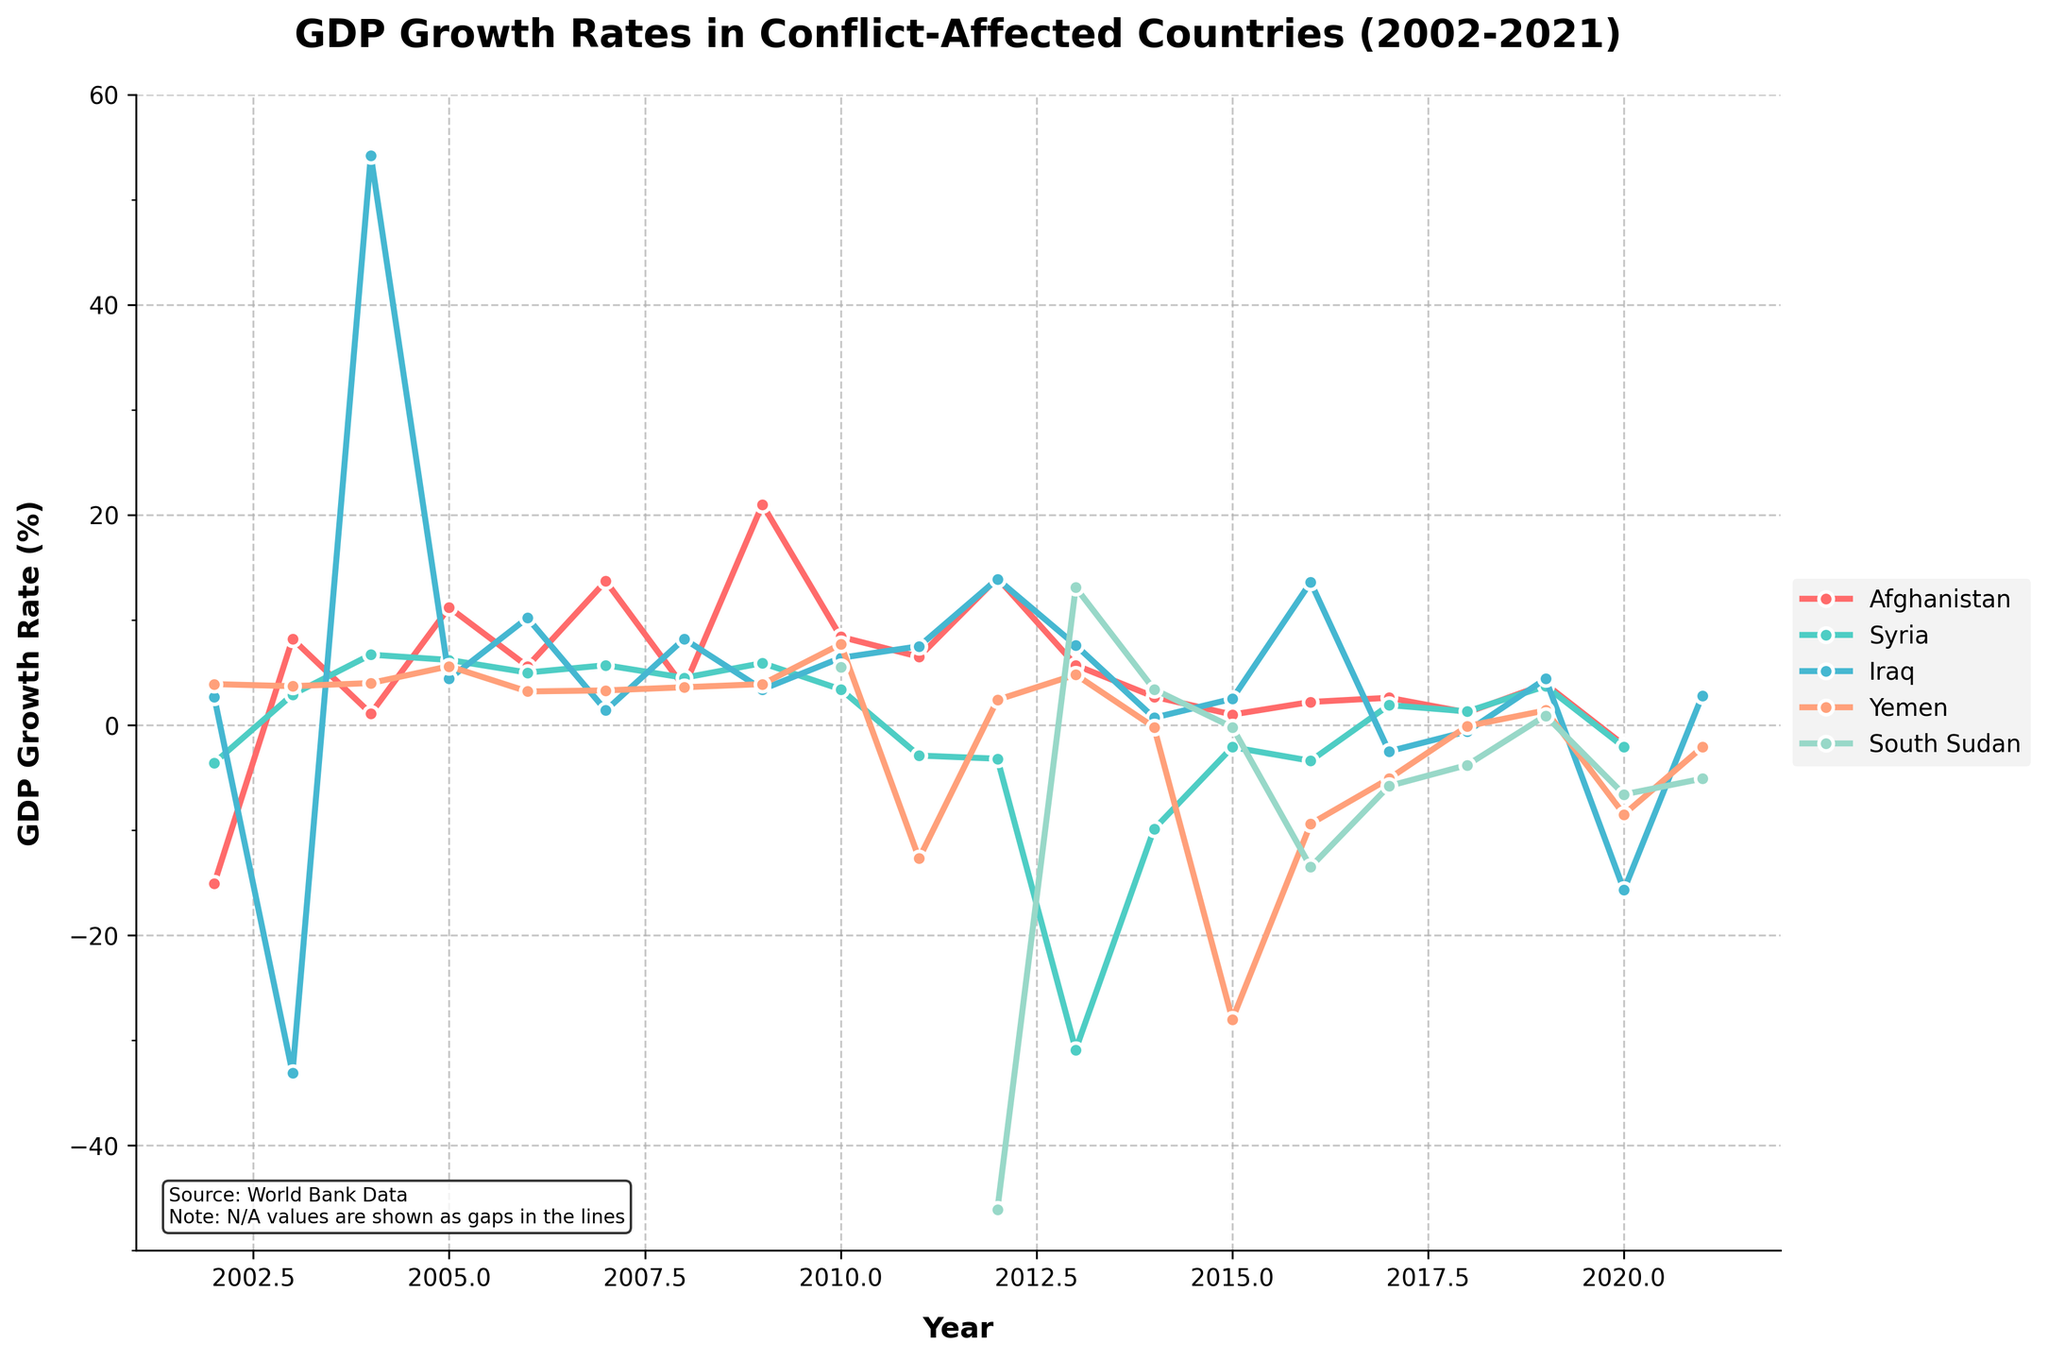What is the overall trend in Afghanistan's GDP growth rate from 2002 to 2021? Afghanistan's GDP growth rate generally fluctuated over the years, experiencing notable peaks in 2003, 2009, 2012, and 2020, with dips in 2002 and 2015. To analyze the trend effectively, look at the trajectory where it has ups and downs but shows periods of significant growth followed by declines, suggesting instability.
Answer: Fluctuating Which country experienced the lowest GDP growth rate in any given year, and what was that rate? Observing the data lines, South Sudan had the lowest GDP growth rate at -46.1% in 2012. This is determined by scanning the graph for the minimum point across all countries and all years.
Answer: South Sudan, -46.1% Compare the GDP growth rates of Iraq and Yemen in 2015. Which country had a higher growth rate, and by how much? In 2015, Iraq had a GDP growth rate of 2.5%, while Yemen had a growth rate of -28.0%. Subtract Yemen’s growth rate from Iraq’s (2.5 - (-28.0)) to find the difference.
Answer: Iraq by 30.5% In which year did Syria experience its steepest decline in GDP growth rate, and what was the value? By examining the steepest drop in Syria's line on the graph, we find that in 2013, Syria’s GDP growth rate dropped to -30.9%.
Answer: 2013, -30.9% How many years did South Sudan have a negative GDP growth rate since its data availability began in 2010? From 2010 to 2021, South Sudan’s GDP growth rates were negative in 6 out of 11 years (2012, 2015, 2016, 2017, 2018, 2020, and 2021).
Answer: 6 years Which country showed the highest peak in GDP growth, in which year, and what was the rate? By identifying the highest peak across all lines, Iraq’s GDP growth rate peaked at 54.2% in 2004.
Answer: Iraq, 2004, 54.2% From 2010 to 2015, which country had the most consistent GDP growth rate, and what does the pattern suggest? Reviewing each country’s line, Syria’s GDP growth rate appears relatively consistent during this period, mostly hovering around zero at negative values despite large initial drops. The small differences between consecutive years indicate consistency.
Answer: Syria, consistent negative growth What was the GDP growth rate difference between Afghanistan and South Sudan in 2010? In 2010, Afghanistan had a GDP growth rate of 8.4%, while South Sudan's was 5.5%. Subtract South Sudan's rate from Afghanistan's (8.4 - 5.5) to find the difference.
Answer: 2.9% Which country had a continuous negative GDP growth rate from 2017 to 2021? South Sudan had a continuous negative GDP growth rate from 2017 to 2021, visible by following South Sudan's line across these years on the graph.
Answer: South Sudan Considering all years, which country had the most volatile GDP growth rate? By observing significant peaks and valleys in the graph, Iraq's GDP line shows substantial variability compared to others, indicating high volatility.
Answer: Iraq 